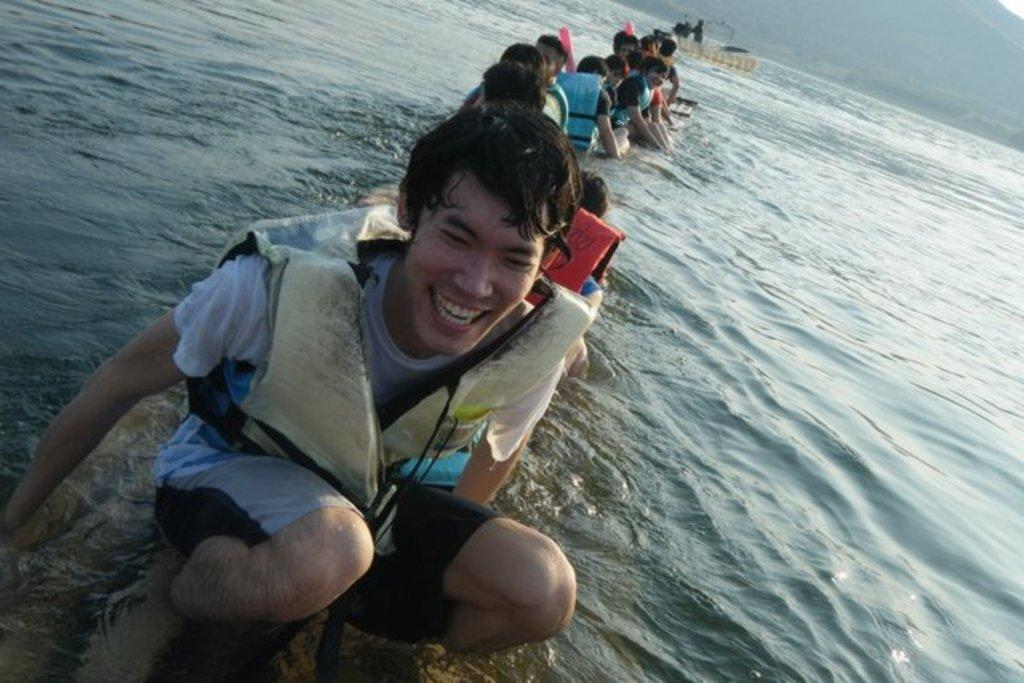How many people are in the image? There is a group of people in the image. What are the people doing in the image? The people are sitting in a boat. Where is the boat located in the image? The boat is on the water. What can be seen in the background of the image? The sky is visible in the background of the image. What is the color of the sky in the image? The color of the sky is white. Who is the creator of the scene in the image? The image is a photograph or illustration, not a scene created by a person, so there is no specific creator to identify. 